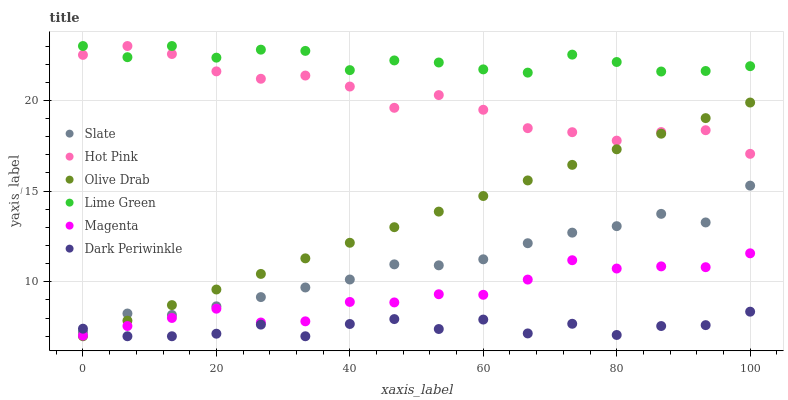Does Dark Periwinkle have the minimum area under the curve?
Answer yes or no. Yes. Does Lime Green have the maximum area under the curve?
Answer yes or no. Yes. Does Hot Pink have the minimum area under the curve?
Answer yes or no. No. Does Hot Pink have the maximum area under the curve?
Answer yes or no. No. Is Olive Drab the smoothest?
Answer yes or no. Yes. Is Dark Periwinkle the roughest?
Answer yes or no. Yes. Is Hot Pink the smoothest?
Answer yes or no. No. Is Hot Pink the roughest?
Answer yes or no. No. Does Dark Periwinkle have the lowest value?
Answer yes or no. Yes. Does Hot Pink have the lowest value?
Answer yes or no. No. Does Lime Green have the highest value?
Answer yes or no. Yes. Does Magenta have the highest value?
Answer yes or no. No. Is Slate less than Hot Pink?
Answer yes or no. Yes. Is Lime Green greater than Dark Periwinkle?
Answer yes or no. Yes. Does Slate intersect Olive Drab?
Answer yes or no. Yes. Is Slate less than Olive Drab?
Answer yes or no. No. Is Slate greater than Olive Drab?
Answer yes or no. No. Does Slate intersect Hot Pink?
Answer yes or no. No. 